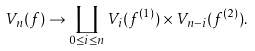Convert formula to latex. <formula><loc_0><loc_0><loc_500><loc_500>V _ { n } ( f ) \to \coprod _ { 0 \leq i \leq n } V _ { i } ( f ^ { ( 1 ) } ) \times V _ { n - i } ( f ^ { ( 2 ) } ) .</formula> 